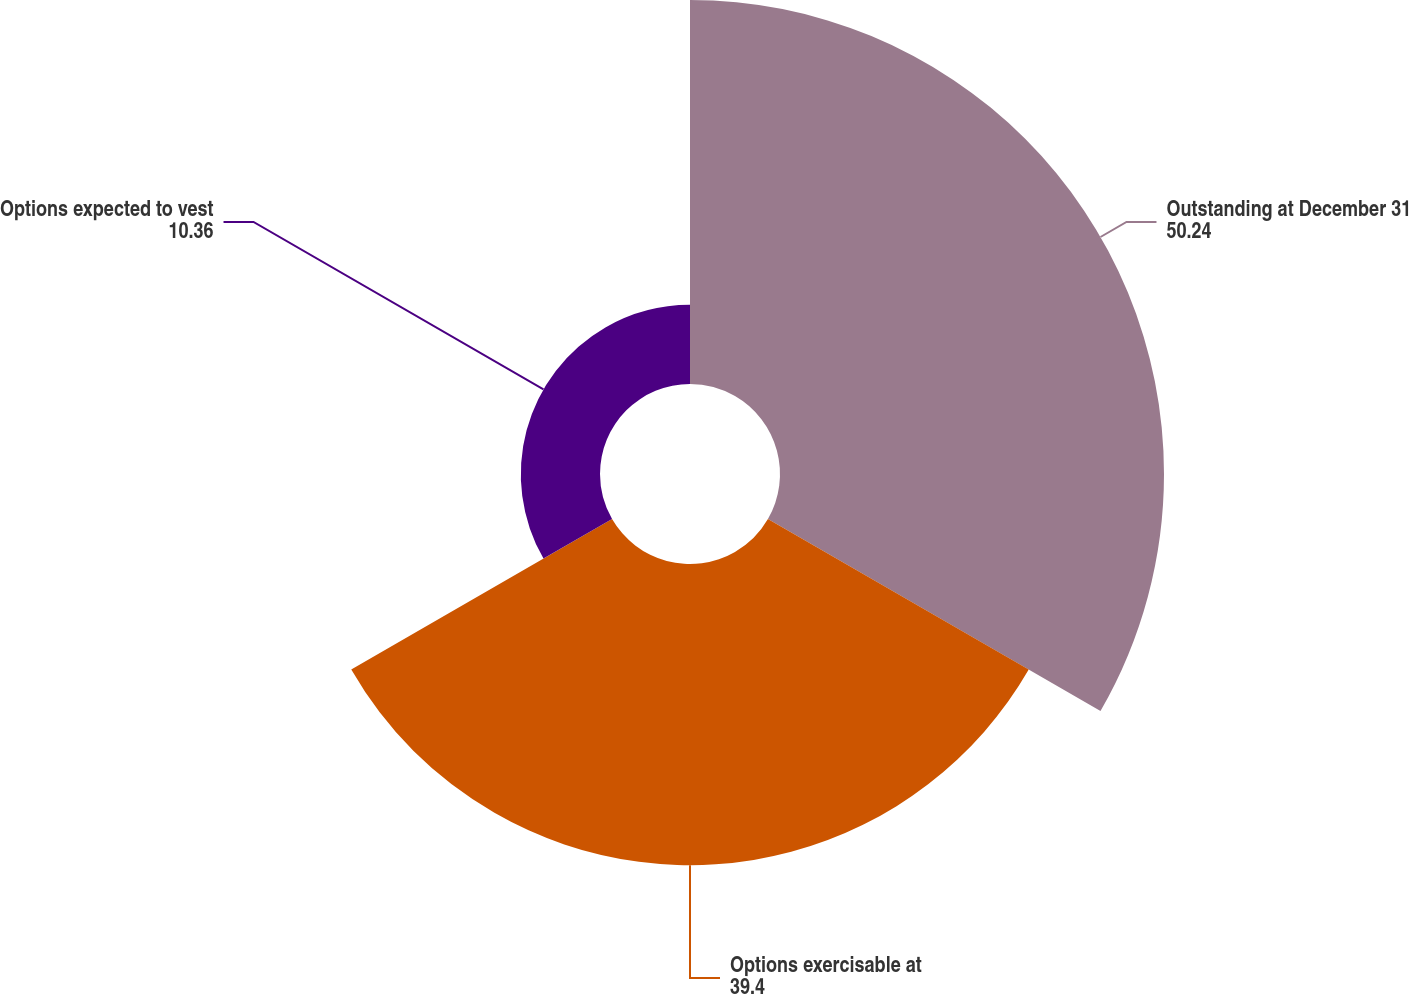Convert chart to OTSL. <chart><loc_0><loc_0><loc_500><loc_500><pie_chart><fcel>Outstanding at December 31<fcel>Options exercisable at<fcel>Options expected to vest<nl><fcel>50.24%<fcel>39.4%<fcel>10.36%<nl></chart> 